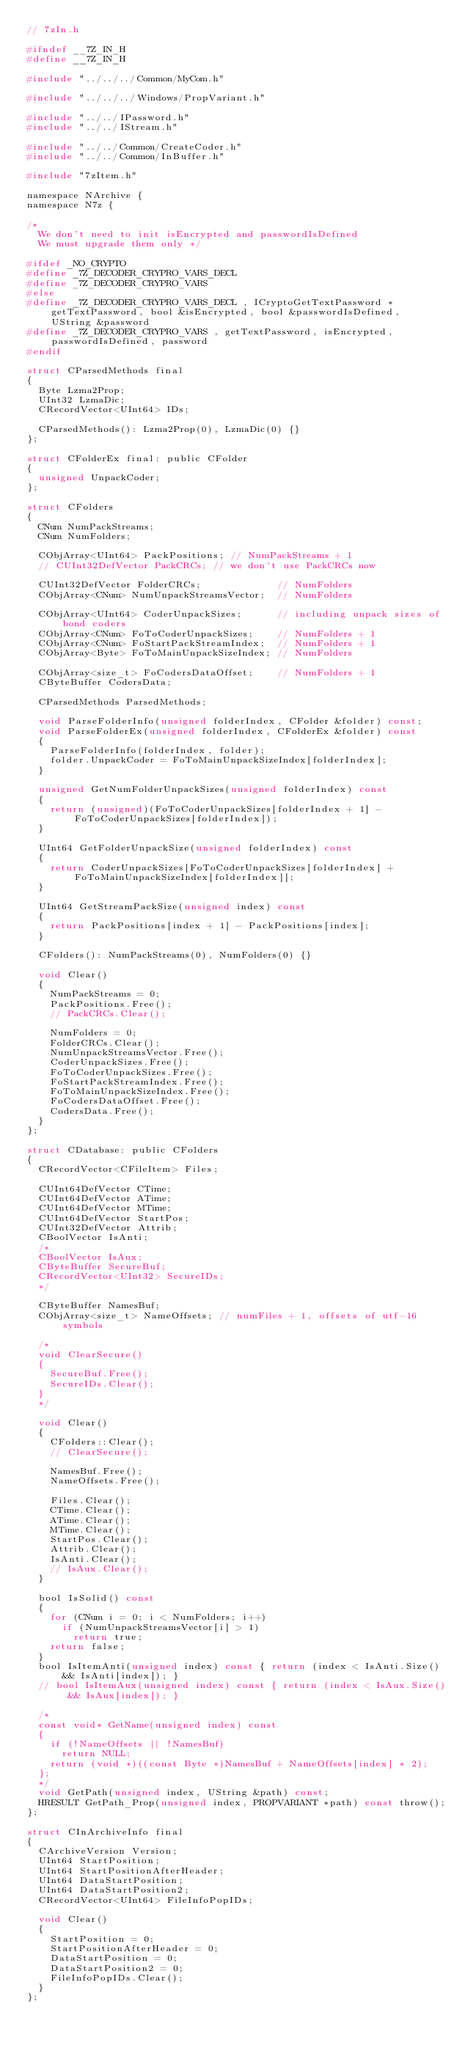Convert code to text. <code><loc_0><loc_0><loc_500><loc_500><_C_>// 7zIn.h

#ifndef __7Z_IN_H
#define __7Z_IN_H

#include "../../../Common/MyCom.h"

#include "../../../Windows/PropVariant.h"

#include "../../IPassword.h"
#include "../../IStream.h"

#include "../../Common/CreateCoder.h"
#include "../../Common/InBuffer.h"

#include "7zItem.h"
 
namespace NArchive {
namespace N7z {

/*
  We don't need to init isEncrypted and passwordIsDefined
  We must upgrade them only */

#ifdef _NO_CRYPTO
#define _7Z_DECODER_CRYPRO_VARS_DECL
#define _7Z_DECODER_CRYPRO_VARS
#else
#define _7Z_DECODER_CRYPRO_VARS_DECL , ICryptoGetTextPassword *getTextPassword, bool &isEncrypted, bool &passwordIsDefined, UString &password
#define _7Z_DECODER_CRYPRO_VARS , getTextPassword, isEncrypted, passwordIsDefined, password
#endif

struct CParsedMethods final
{
  Byte Lzma2Prop;
  UInt32 LzmaDic;
  CRecordVector<UInt64> IDs;

  CParsedMethods(): Lzma2Prop(0), LzmaDic(0) {}
};

struct CFolderEx final: public CFolder
{
  unsigned UnpackCoder;
};

struct CFolders
{
  CNum NumPackStreams;
  CNum NumFolders;

  CObjArray<UInt64> PackPositions; // NumPackStreams + 1
  // CUInt32DefVector PackCRCs; // we don't use PackCRCs now

  CUInt32DefVector FolderCRCs;             // NumFolders
  CObjArray<CNum> NumUnpackStreamsVector;  // NumFolders

  CObjArray<UInt64> CoderUnpackSizes;      // including unpack sizes of bond coders
  CObjArray<CNum> FoToCoderUnpackSizes;    // NumFolders + 1
  CObjArray<CNum> FoStartPackStreamIndex;  // NumFolders + 1
  CObjArray<Byte> FoToMainUnpackSizeIndex; // NumFolders
  
  CObjArray<size_t> FoCodersDataOffset;    // NumFolders + 1
  CByteBuffer CodersData;

  CParsedMethods ParsedMethods;

  void ParseFolderInfo(unsigned folderIndex, CFolder &folder) const;
  void ParseFolderEx(unsigned folderIndex, CFolderEx &folder) const
  {
    ParseFolderInfo(folderIndex, folder);
    folder.UnpackCoder = FoToMainUnpackSizeIndex[folderIndex];
  }
  
  unsigned GetNumFolderUnpackSizes(unsigned folderIndex) const
  {
    return (unsigned)(FoToCoderUnpackSizes[folderIndex + 1] - FoToCoderUnpackSizes[folderIndex]);
  }

  UInt64 GetFolderUnpackSize(unsigned folderIndex) const
  {
    return CoderUnpackSizes[FoToCoderUnpackSizes[folderIndex] + FoToMainUnpackSizeIndex[folderIndex]];
  }

  UInt64 GetStreamPackSize(unsigned index) const
  {
    return PackPositions[index + 1] - PackPositions[index];
  }

  CFolders(): NumPackStreams(0), NumFolders(0) {}

  void Clear()
  {
    NumPackStreams = 0;
    PackPositions.Free();
    // PackCRCs.Clear();

    NumFolders = 0;
    FolderCRCs.Clear();
    NumUnpackStreamsVector.Free();
    CoderUnpackSizes.Free();
    FoToCoderUnpackSizes.Free();
    FoStartPackStreamIndex.Free();
    FoToMainUnpackSizeIndex.Free();
    FoCodersDataOffset.Free();
    CodersData.Free();
  }
};

struct CDatabase: public CFolders
{
  CRecordVector<CFileItem> Files;

  CUInt64DefVector CTime;
  CUInt64DefVector ATime;
  CUInt64DefVector MTime;
  CUInt64DefVector StartPos;
  CUInt32DefVector Attrib;
  CBoolVector IsAnti;
  /*
  CBoolVector IsAux;
  CByteBuffer SecureBuf;
  CRecordVector<UInt32> SecureIDs;
  */

  CByteBuffer NamesBuf;
  CObjArray<size_t> NameOffsets; // numFiles + 1, offsets of utf-16 symbols

  /*
  void ClearSecure()
  {
    SecureBuf.Free();
    SecureIDs.Clear();
  }
  */

  void Clear()
  {
    CFolders::Clear();
    // ClearSecure();

    NamesBuf.Free();
    NameOffsets.Free();
    
    Files.Clear();
    CTime.Clear();
    ATime.Clear();
    MTime.Clear();
    StartPos.Clear();
    Attrib.Clear();
    IsAnti.Clear();
    // IsAux.Clear();
  }

  bool IsSolid() const
  {
    for (CNum i = 0; i < NumFolders; i++)
      if (NumUnpackStreamsVector[i] > 1)
        return true;
    return false;
  }
  bool IsItemAnti(unsigned index) const { return (index < IsAnti.Size() && IsAnti[index]); }
  // bool IsItemAux(unsigned index) const { return (index < IsAux.Size() && IsAux[index]); }

  /*
  const void* GetName(unsigned index) const
  {
    if (!NameOffsets || !NamesBuf)
      return NULL;
    return (void *)((const Byte *)NamesBuf + NameOffsets[index] * 2);
  };
  */
  void GetPath(unsigned index, UString &path) const;
  HRESULT GetPath_Prop(unsigned index, PROPVARIANT *path) const throw();
};

struct CInArchiveInfo final
{
  CArchiveVersion Version;
  UInt64 StartPosition;
  UInt64 StartPositionAfterHeader;
  UInt64 DataStartPosition;
  UInt64 DataStartPosition2;
  CRecordVector<UInt64> FileInfoPopIDs;
  
  void Clear()
  {
    StartPosition = 0;
    StartPositionAfterHeader = 0;
    DataStartPosition = 0;
    DataStartPosition2 = 0;
    FileInfoPopIDs.Clear();
  }
};
</code> 